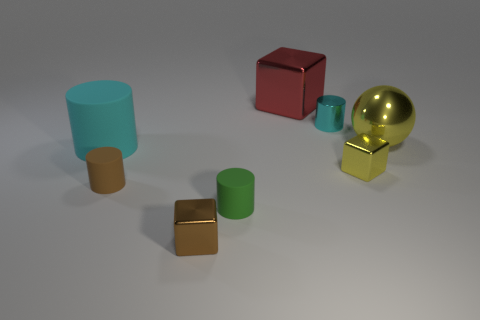Subtract all big rubber cylinders. How many cylinders are left? 3 Add 1 big green rubber things. How many objects exist? 9 Subtract all yellow cubes. How many cubes are left? 2 Subtract all balls. How many objects are left? 7 Subtract 2 blocks. How many blocks are left? 1 Subtract all red spheres. How many red cubes are left? 1 Subtract all green matte cylinders. Subtract all big objects. How many objects are left? 4 Add 4 red metal blocks. How many red metal blocks are left? 5 Add 6 big rubber things. How many big rubber things exist? 7 Subtract 0 cyan balls. How many objects are left? 8 